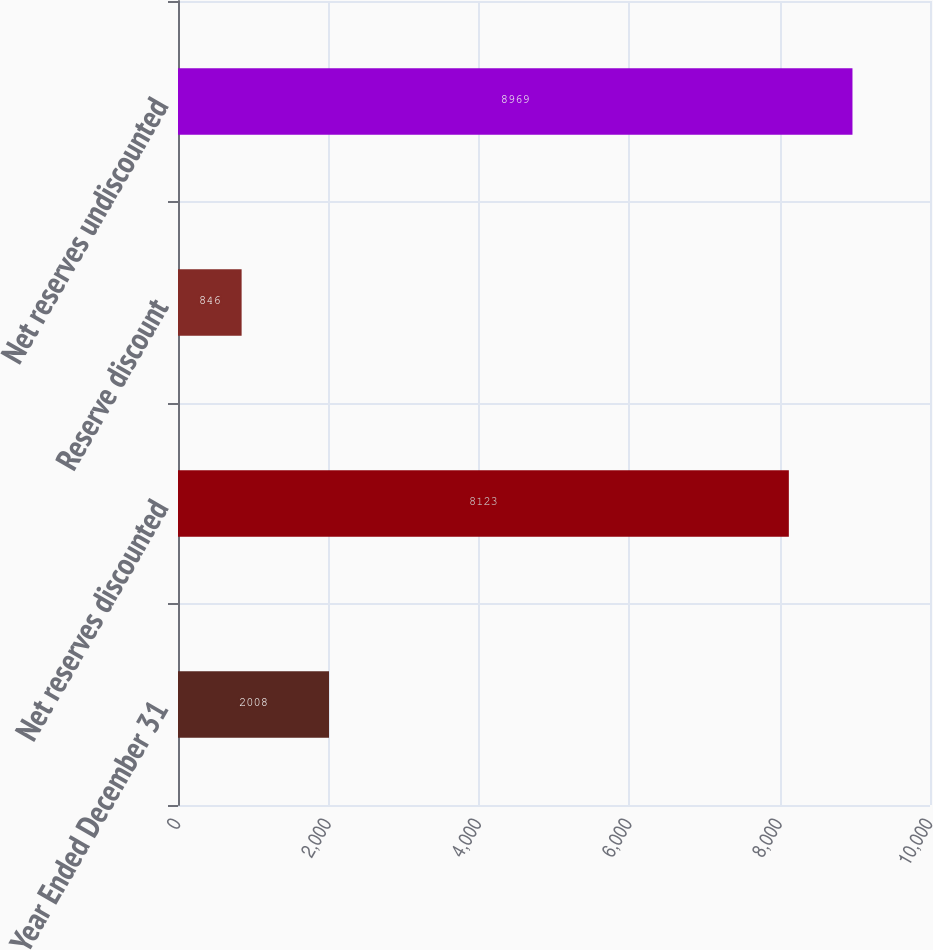Convert chart to OTSL. <chart><loc_0><loc_0><loc_500><loc_500><bar_chart><fcel>Year Ended December 31<fcel>Net reserves discounted<fcel>Reserve discount<fcel>Net reserves undiscounted<nl><fcel>2008<fcel>8123<fcel>846<fcel>8969<nl></chart> 